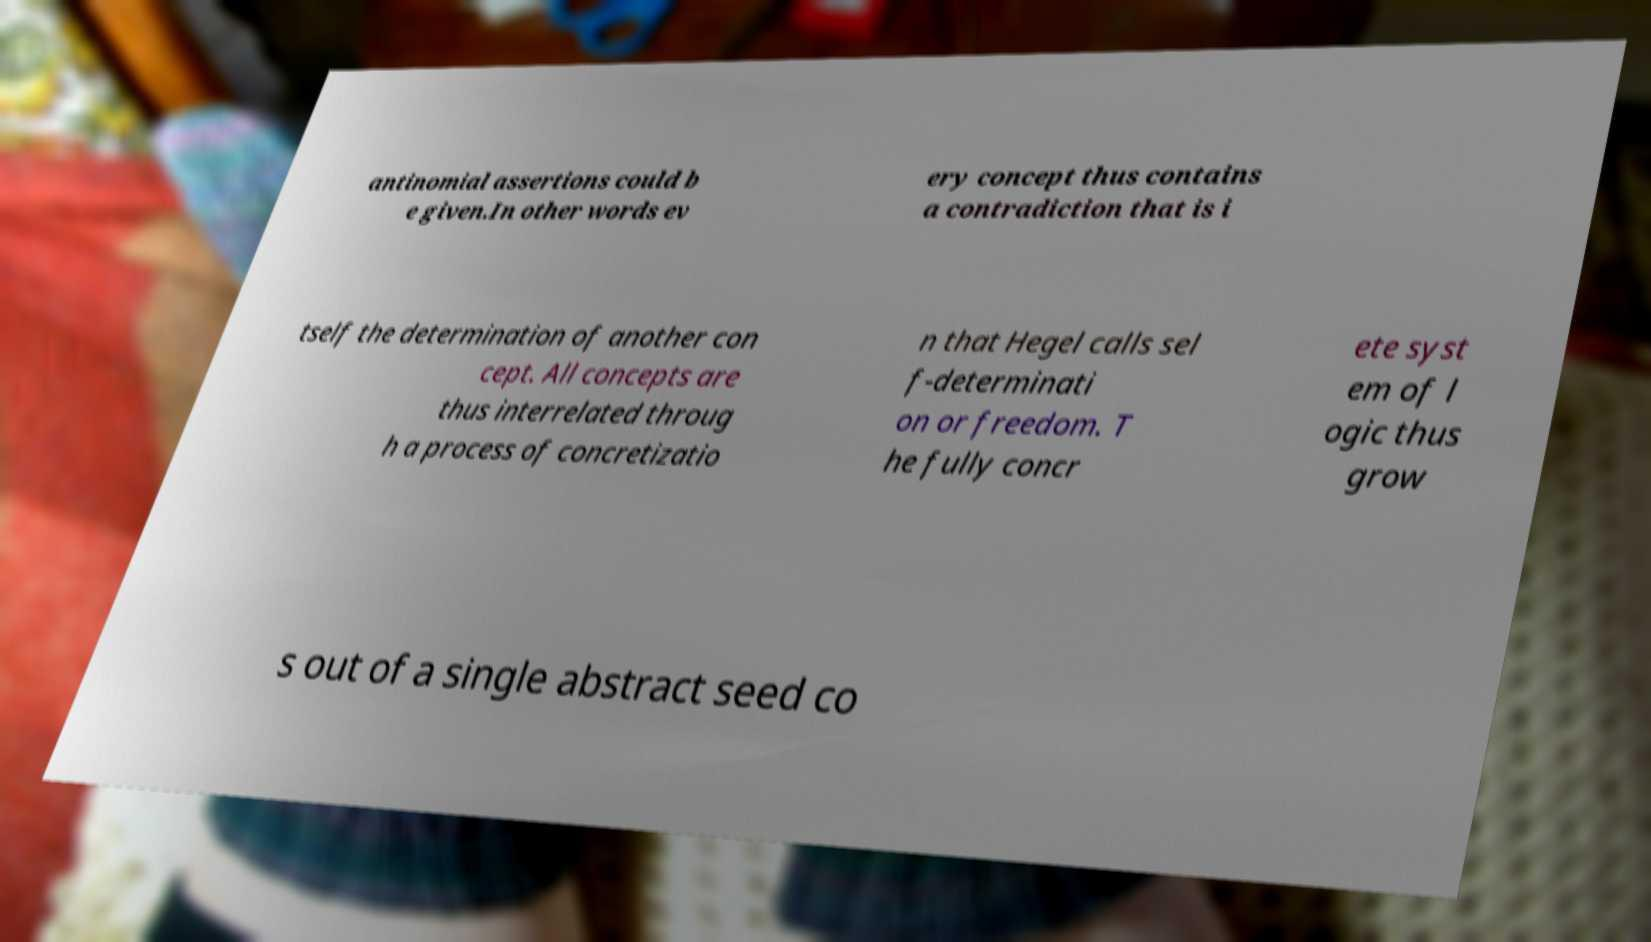What messages or text are displayed in this image? I need them in a readable, typed format. antinomial assertions could b e given.In other words ev ery concept thus contains a contradiction that is i tself the determination of another con cept. All concepts are thus interrelated throug h a process of concretizatio n that Hegel calls sel f-determinati on or freedom. T he fully concr ete syst em of l ogic thus grow s out of a single abstract seed co 